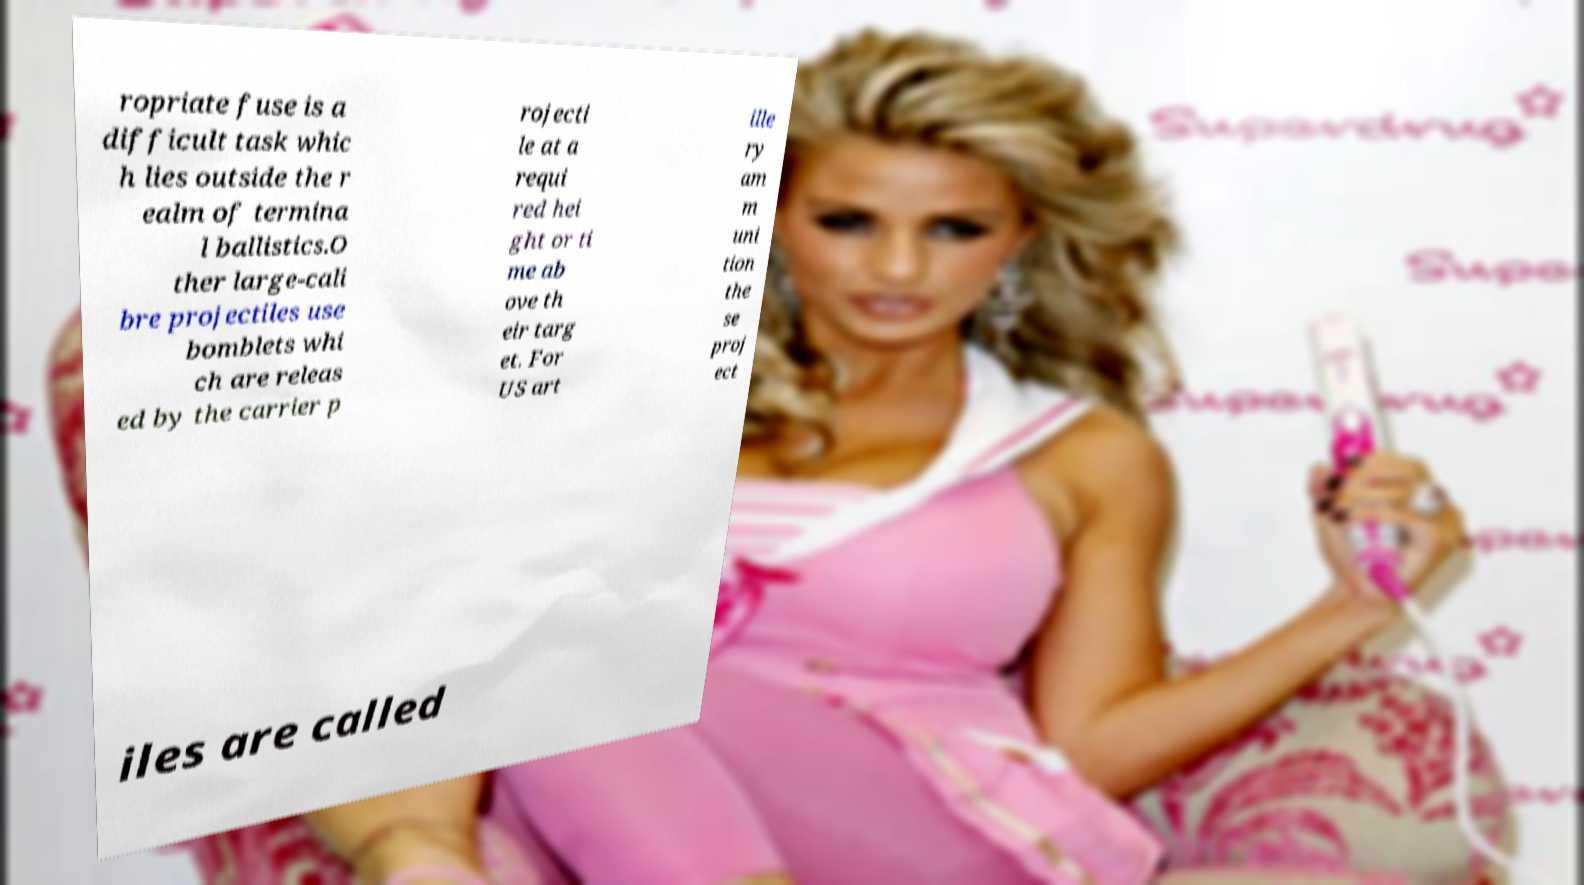For documentation purposes, I need the text within this image transcribed. Could you provide that? ropriate fuse is a difficult task whic h lies outside the r ealm of termina l ballistics.O ther large-cali bre projectiles use bomblets whi ch are releas ed by the carrier p rojecti le at a requi red hei ght or ti me ab ove th eir targ et. For US art ille ry am m uni tion the se proj ect iles are called 